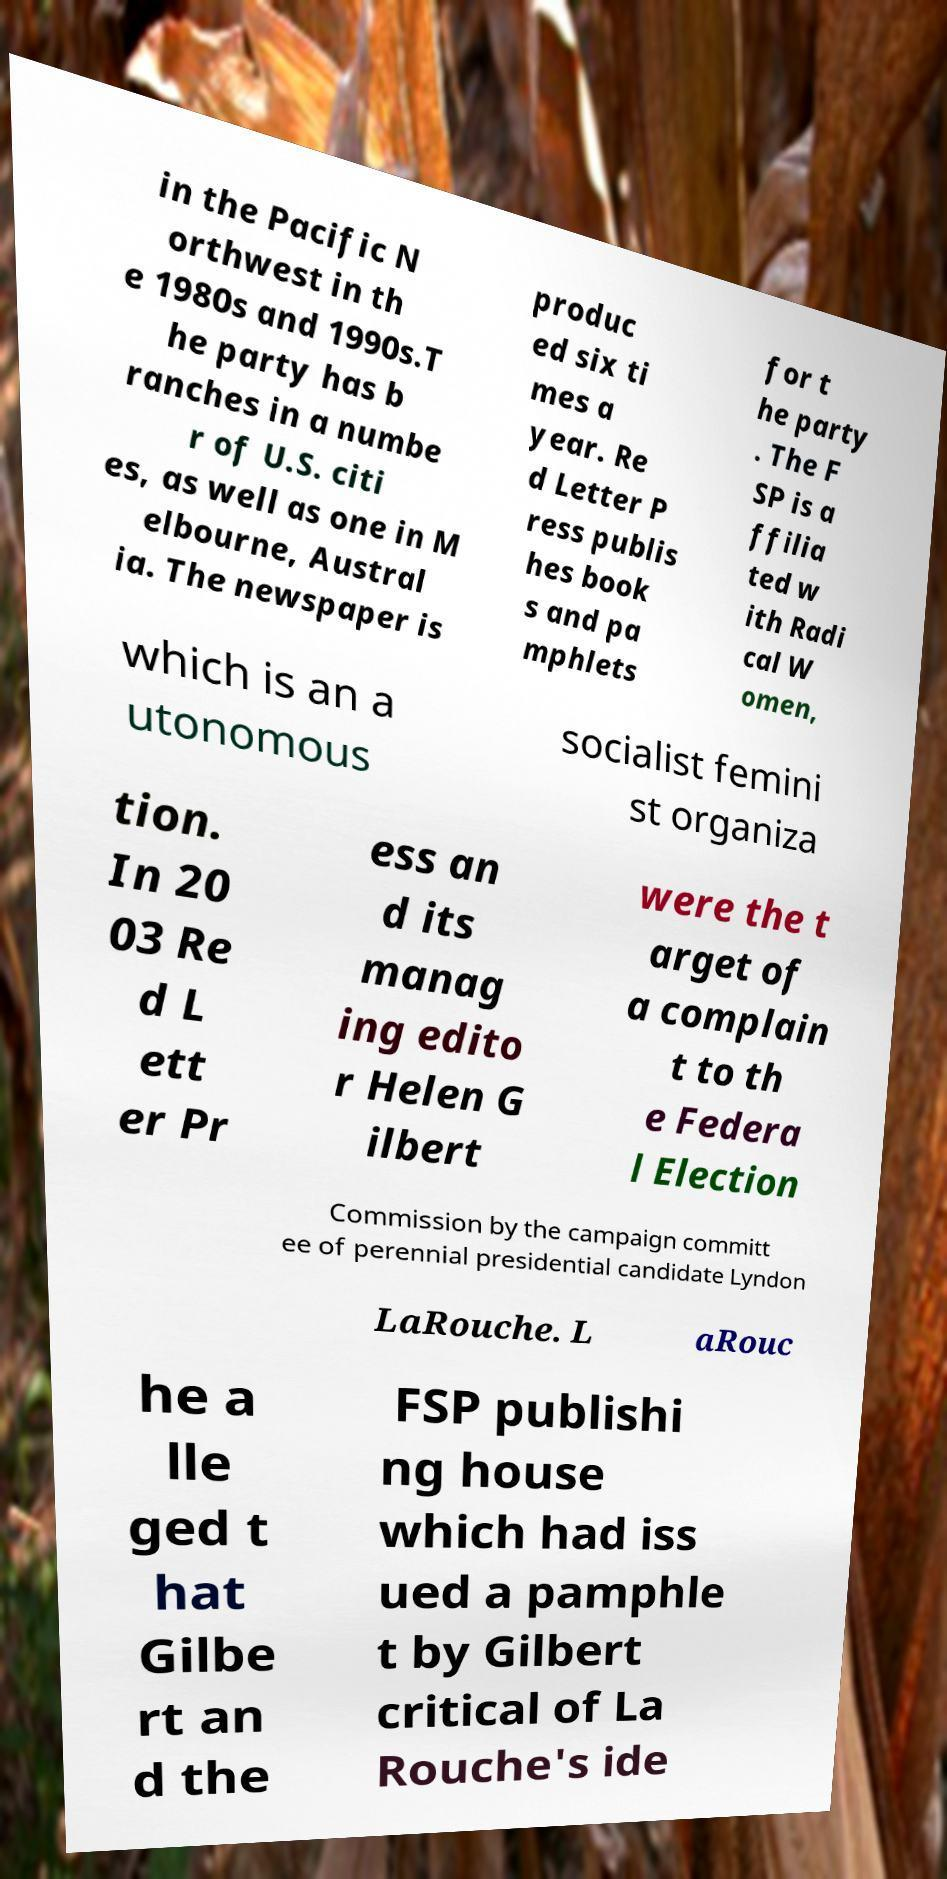What messages or text are displayed in this image? I need them in a readable, typed format. in the Pacific N orthwest in th e 1980s and 1990s.T he party has b ranches in a numbe r of U.S. citi es, as well as one in M elbourne, Austral ia. The newspaper is produc ed six ti mes a year. Re d Letter P ress publis hes book s and pa mphlets for t he party . The F SP is a ffilia ted w ith Radi cal W omen, which is an a utonomous socialist femini st organiza tion. In 20 03 Re d L ett er Pr ess an d its manag ing edito r Helen G ilbert were the t arget of a complain t to th e Federa l Election Commission by the campaign committ ee of perennial presidential candidate Lyndon LaRouche. L aRouc he a lle ged t hat Gilbe rt an d the FSP publishi ng house which had iss ued a pamphle t by Gilbert critical of La Rouche's ide 